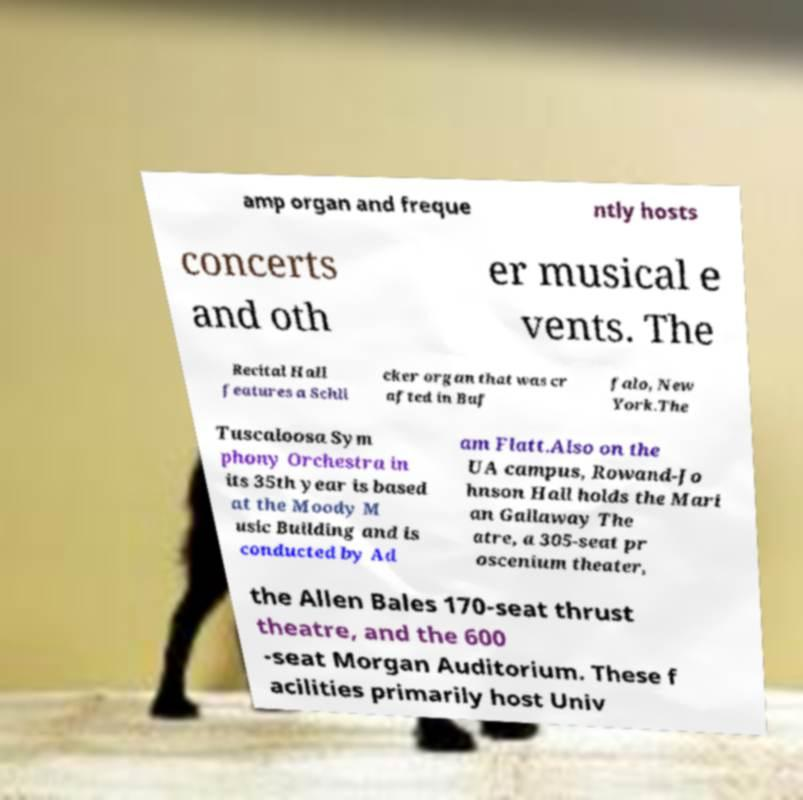There's text embedded in this image that I need extracted. Can you transcribe it verbatim? amp organ and freque ntly hosts concerts and oth er musical e vents. The Recital Hall features a Schli cker organ that was cr afted in Buf falo, New York.The Tuscaloosa Sym phony Orchestra in its 35th year is based at the Moody M usic Building and is conducted by Ad am Flatt.Also on the UA campus, Rowand-Jo hnson Hall holds the Mari an Gallaway The atre, a 305-seat pr oscenium theater, the Allen Bales 170-seat thrust theatre, and the 600 -seat Morgan Auditorium. These f acilities primarily host Univ 